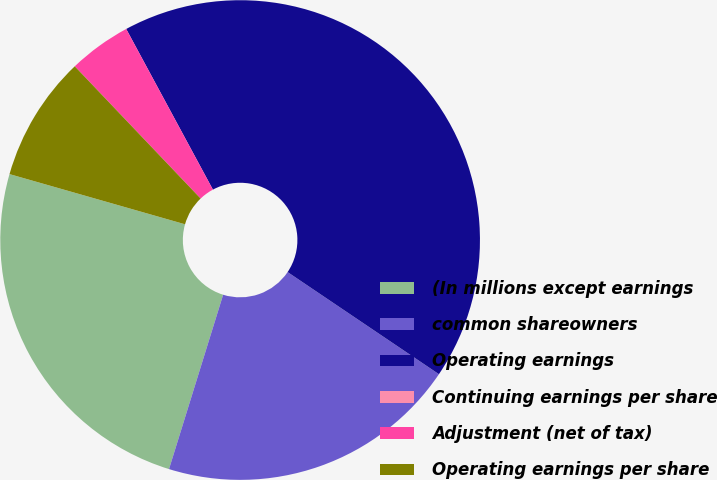<chart> <loc_0><loc_0><loc_500><loc_500><pie_chart><fcel>(In millions except earnings<fcel>common shareowners<fcel>Operating earnings<fcel>Continuing earnings per share<fcel>Adjustment (net of tax)<fcel>Operating earnings per share<nl><fcel>24.64%<fcel>20.34%<fcel>42.32%<fcel>0.0%<fcel>4.23%<fcel>8.46%<nl></chart> 